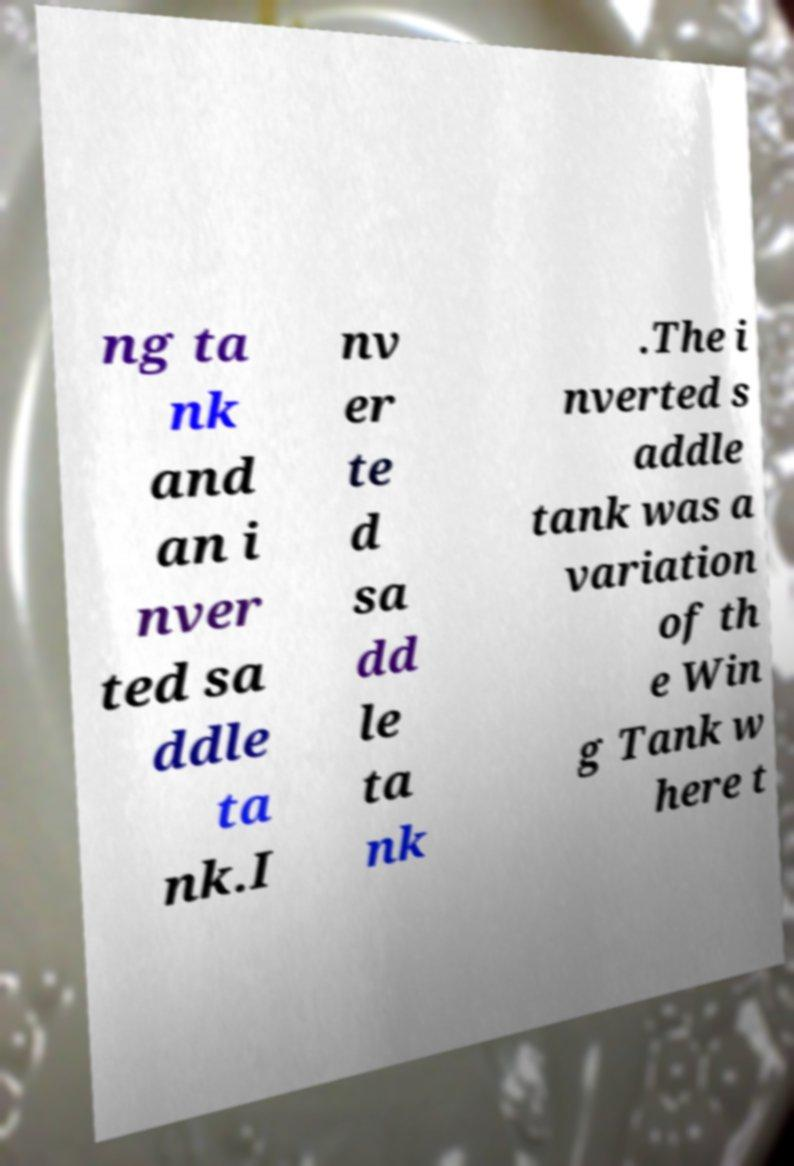I need the written content from this picture converted into text. Can you do that? ng ta nk and an i nver ted sa ddle ta nk.I nv er te d sa dd le ta nk .The i nverted s addle tank was a variation of th e Win g Tank w here t 